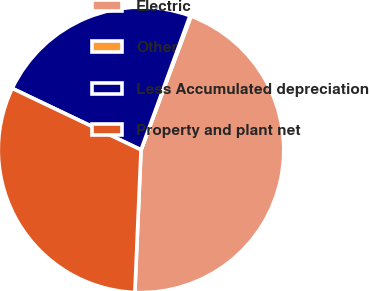Convert chart. <chart><loc_0><loc_0><loc_500><loc_500><pie_chart><fcel>Electric<fcel>Other<fcel>Less Accumulated depreciation<fcel>Property and plant net<nl><fcel>44.99%<fcel>0.13%<fcel>23.48%<fcel>31.4%<nl></chart> 